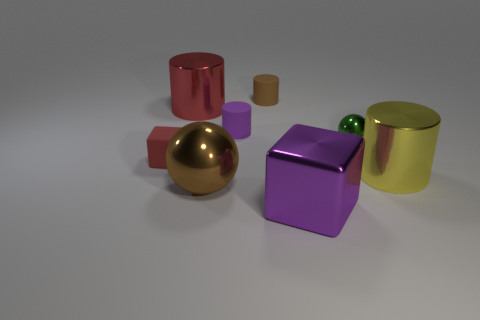What number of other objects are there of the same size as the red cube?
Offer a very short reply. 3. Is there anything else that is the same color as the small metal sphere?
Ensure brevity in your answer.  No. What is the material of the big object that is the same shape as the small metallic thing?
Give a very brief answer. Metal. What number of other things are the same shape as the brown rubber thing?
Your response must be concise. 3. How many red objects are right of the cube to the left of the large shiny cylinder that is left of the purple cube?
Keep it short and to the point. 1. What number of other tiny things are the same shape as the tiny purple matte thing?
Keep it short and to the point. 1. Does the large metallic cylinder that is behind the small block have the same color as the rubber block?
Offer a terse response. Yes. What is the shape of the large shiny object behind the purple thing to the left of the purple thing that is in front of the matte cube?
Your response must be concise. Cylinder. Do the purple shiny thing and the sphere that is right of the large purple metal object have the same size?
Ensure brevity in your answer.  No. Is there a metal cylinder that has the same size as the brown shiny thing?
Provide a short and direct response. Yes. 